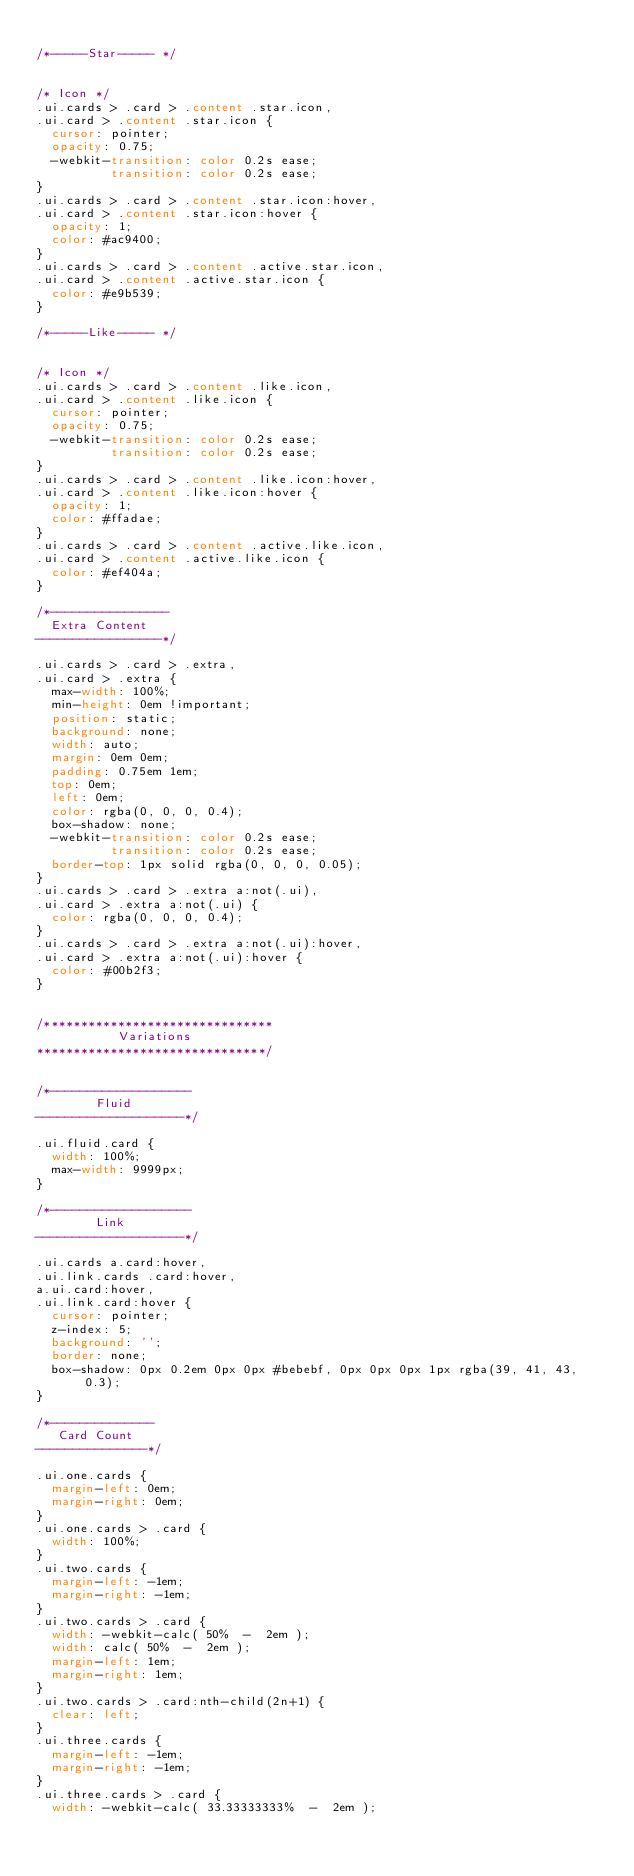<code> <loc_0><loc_0><loc_500><loc_500><_CSS_>
/*-----Star----- */


/* Icon */
.ui.cards > .card > .content .star.icon,
.ui.card > .content .star.icon {
  cursor: pointer;
  opacity: 0.75;
  -webkit-transition: color 0.2s ease;
          transition: color 0.2s ease;
}
.ui.cards > .card > .content .star.icon:hover,
.ui.card > .content .star.icon:hover {
  opacity: 1;
  color: #ac9400;
}
.ui.cards > .card > .content .active.star.icon,
.ui.card > .content .active.star.icon {
  color: #e9b539;
}

/*-----Like----- */


/* Icon */
.ui.cards > .card > .content .like.icon,
.ui.card > .content .like.icon {
  cursor: pointer;
  opacity: 0.75;
  -webkit-transition: color 0.2s ease;
          transition: color 0.2s ease;
}
.ui.cards > .card > .content .like.icon:hover,
.ui.card > .content .like.icon:hover {
  opacity: 1;
  color: #ffadae;
}
.ui.cards > .card > .content .active.like.icon,
.ui.card > .content .active.like.icon {
  color: #ef404a;
}

/*----------------
  Extra Content
-----------------*/

.ui.cards > .card > .extra,
.ui.card > .extra {
  max-width: 100%;
  min-height: 0em !important;
  position: static;
  background: none;
  width: auto;
  margin: 0em 0em;
  padding: 0.75em 1em;
  top: 0em;
  left: 0em;
  color: rgba(0, 0, 0, 0.4);
  box-shadow: none;
  -webkit-transition: color 0.2s ease;
          transition: color 0.2s ease;
  border-top: 1px solid rgba(0, 0, 0, 0.05);
}
.ui.cards > .card > .extra a:not(.ui),
.ui.card > .extra a:not(.ui) {
  color: rgba(0, 0, 0, 0.4);
}
.ui.cards > .card > .extra a:not(.ui):hover,
.ui.card > .extra a:not(.ui):hover {
  color: #00b2f3;
}


/*******************************
           Variations
*******************************/


/*-------------------
        Fluid
--------------------*/

.ui.fluid.card {
  width: 100%;
  max-width: 9999px;
}

/*-------------------
        Link
--------------------*/

.ui.cards a.card:hover,
.ui.link.cards .card:hover,
a.ui.card:hover,
.ui.link.card:hover {
  cursor: pointer;
  z-index: 5;
  background: '';
  border: none;
  box-shadow: 0px 0.2em 0px 0px #bebebf, 0px 0px 0px 1px rgba(39, 41, 43, 0.3);
}

/*--------------
   Card Count
---------------*/

.ui.one.cards {
  margin-left: 0em;
  margin-right: 0em;
}
.ui.one.cards > .card {
  width: 100%;
}
.ui.two.cards {
  margin-left: -1em;
  margin-right: -1em;
}
.ui.two.cards > .card {
  width: -webkit-calc( 50%  -  2em );
  width: calc( 50%  -  2em );
  margin-left: 1em;
  margin-right: 1em;
}
.ui.two.cards > .card:nth-child(2n+1) {
  clear: left;
}
.ui.three.cards {
  margin-left: -1em;
  margin-right: -1em;
}
.ui.three.cards > .card {
  width: -webkit-calc( 33.33333333%  -  2em );</code> 